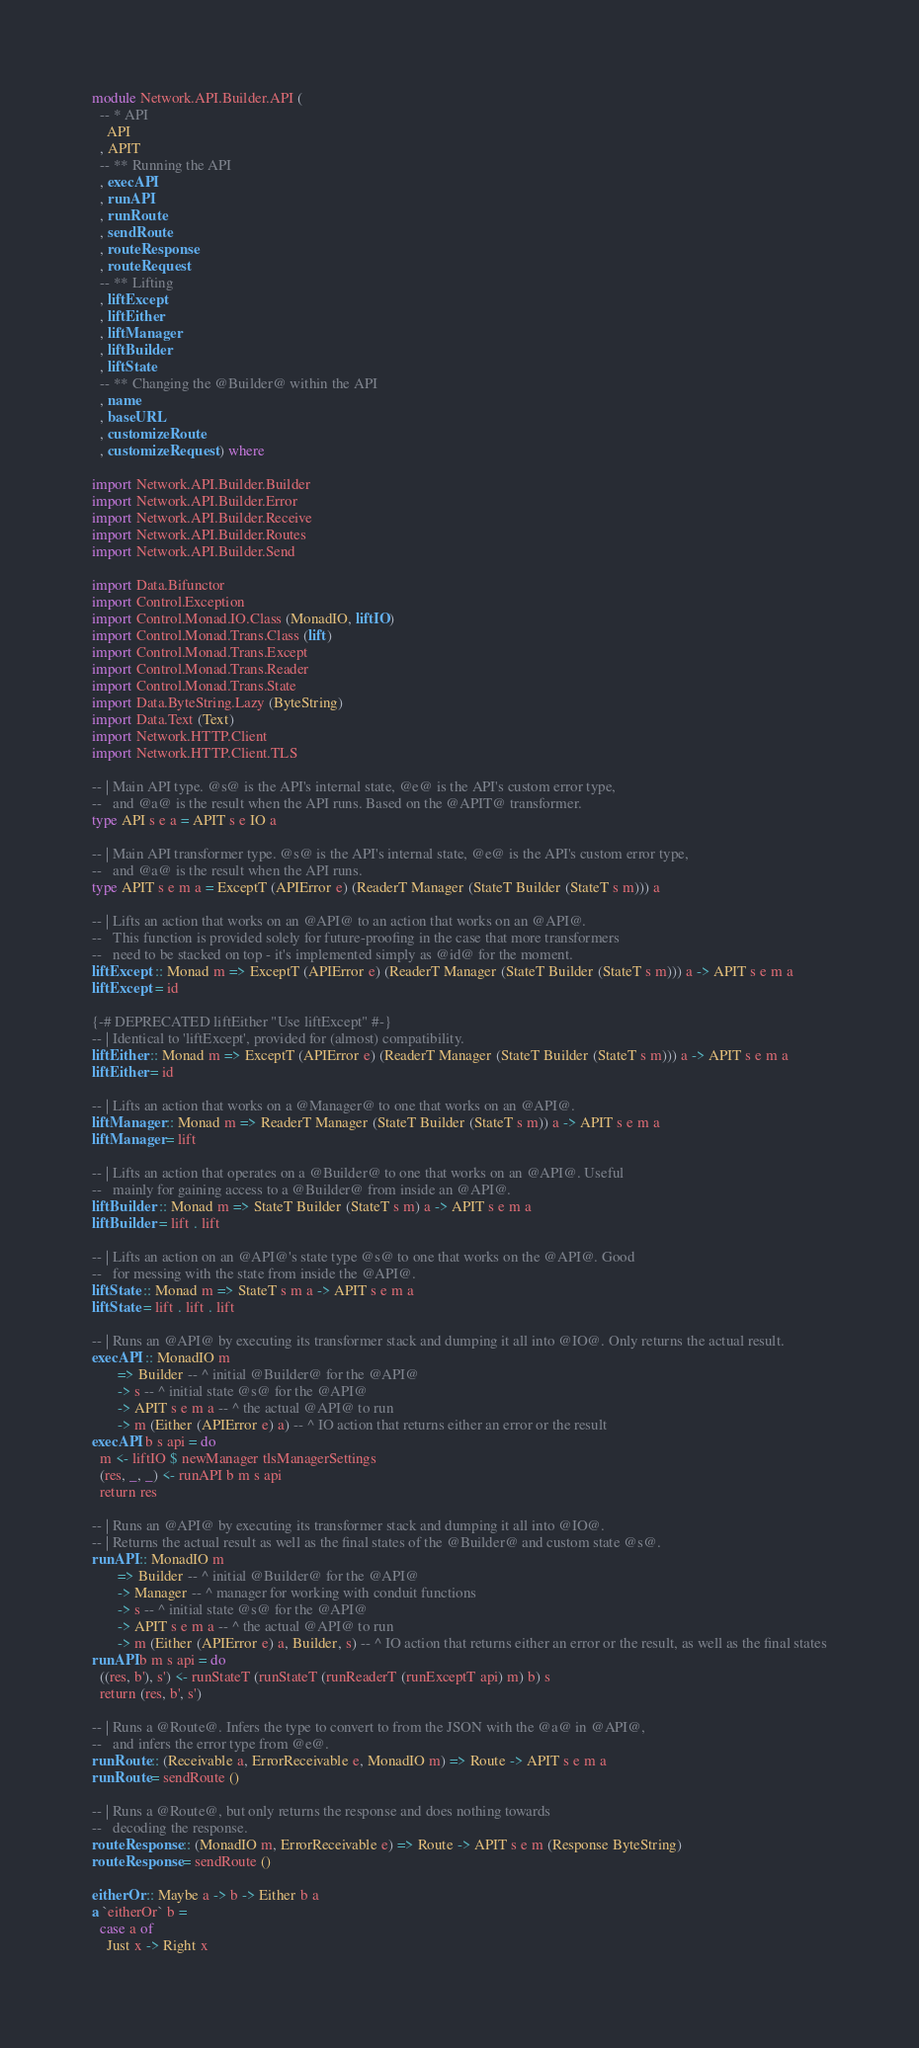Convert code to text. <code><loc_0><loc_0><loc_500><loc_500><_Haskell_>module Network.API.Builder.API (
  -- * API
    API
  , APIT
  -- ** Running the API
  , execAPI
  , runAPI
  , runRoute
  , sendRoute
  , routeResponse
  , routeRequest
  -- ** Lifting
  , liftExcept
  , liftEither
  , liftManager
  , liftBuilder
  , liftState
  -- ** Changing the @Builder@ within the API
  , name
  , baseURL
  , customizeRoute
  , customizeRequest ) where

import Network.API.Builder.Builder
import Network.API.Builder.Error
import Network.API.Builder.Receive
import Network.API.Builder.Routes
import Network.API.Builder.Send

import Data.Bifunctor
import Control.Exception
import Control.Monad.IO.Class (MonadIO, liftIO)
import Control.Monad.Trans.Class (lift)
import Control.Monad.Trans.Except
import Control.Monad.Trans.Reader
import Control.Monad.Trans.State
import Data.ByteString.Lazy (ByteString)
import Data.Text (Text)
import Network.HTTP.Client
import Network.HTTP.Client.TLS

-- | Main API type. @s@ is the API's internal state, @e@ is the API's custom error type,
--   and @a@ is the result when the API runs. Based on the @APIT@ transformer.
type API s e a = APIT s e IO a

-- | Main API transformer type. @s@ is the API's internal state, @e@ is the API's custom error type,
--   and @a@ is the result when the API runs.
type APIT s e m a = ExceptT (APIError e) (ReaderT Manager (StateT Builder (StateT s m))) a

-- | Lifts an action that works on an @API@ to an action that works on an @API@.
--   This function is provided solely for future-proofing in the case that more transformers
--   need to be stacked on top - it's implemented simply as @id@ for the moment.
liftExcept :: Monad m => ExceptT (APIError e) (ReaderT Manager (StateT Builder (StateT s m))) a -> APIT s e m a
liftExcept = id

{-# DEPRECATED liftEither "Use liftExcept" #-}
-- | Identical to 'liftExcept', provided for (almost) compatibility.
liftEither :: Monad m => ExceptT (APIError e) (ReaderT Manager (StateT Builder (StateT s m))) a -> APIT s e m a
liftEither = id

-- | Lifts an action that works on a @Manager@ to one that works on an @API@.
liftManager :: Monad m => ReaderT Manager (StateT Builder (StateT s m)) a -> APIT s e m a
liftManager = lift

-- | Lifts an action that operates on a @Builder@ to one that works on an @API@. Useful
--   mainly for gaining access to a @Builder@ from inside an @API@.
liftBuilder :: Monad m => StateT Builder (StateT s m) a -> APIT s e m a
liftBuilder = lift . lift

-- | Lifts an action on an @API@'s state type @s@ to one that works on the @API@. Good
--   for messing with the state from inside the @API@.
liftState :: Monad m => StateT s m a -> APIT s e m a
liftState = lift . lift . lift

-- | Runs an @API@ by executing its transformer stack and dumping it all into @IO@. Only returns the actual result.
execAPI :: MonadIO m
       => Builder -- ^ initial @Builder@ for the @API@
       -> s -- ^ initial state @s@ for the @API@
       -> APIT s e m a -- ^ the actual @API@ to run
       -> m (Either (APIError e) a) -- ^ IO action that returns either an error or the result
execAPI b s api = do
  m <- liftIO $ newManager tlsManagerSettings
  (res, _, _) <- runAPI b m s api
  return res

-- | Runs an @API@ by executing its transformer stack and dumping it all into @IO@.
-- | Returns the actual result as well as the final states of the @Builder@ and custom state @s@.
runAPI :: MonadIO m
       => Builder -- ^ initial @Builder@ for the @API@
       -> Manager -- ^ manager for working with conduit functions
       -> s -- ^ initial state @s@ for the @API@
       -> APIT s e m a -- ^ the actual @API@ to run
       -> m (Either (APIError e) a, Builder, s) -- ^ IO action that returns either an error or the result, as well as the final states
runAPI b m s api = do
  ((res, b'), s') <- runStateT (runStateT (runReaderT (runExceptT api) m) b) s
  return (res, b', s')

-- | Runs a @Route@. Infers the type to convert to from the JSON with the @a@ in @API@,
--   and infers the error type from @e@.
runRoute :: (Receivable a, ErrorReceivable e, MonadIO m) => Route -> APIT s e m a
runRoute = sendRoute ()

-- | Runs a @Route@, but only returns the response and does nothing towards
--   decoding the response.
routeResponse :: (MonadIO m, ErrorReceivable e) => Route -> APIT s e m (Response ByteString)
routeResponse = sendRoute ()

eitherOr :: Maybe a -> b -> Either b a
a `eitherOr` b =
  case a of
    Just x -> Right x</code> 